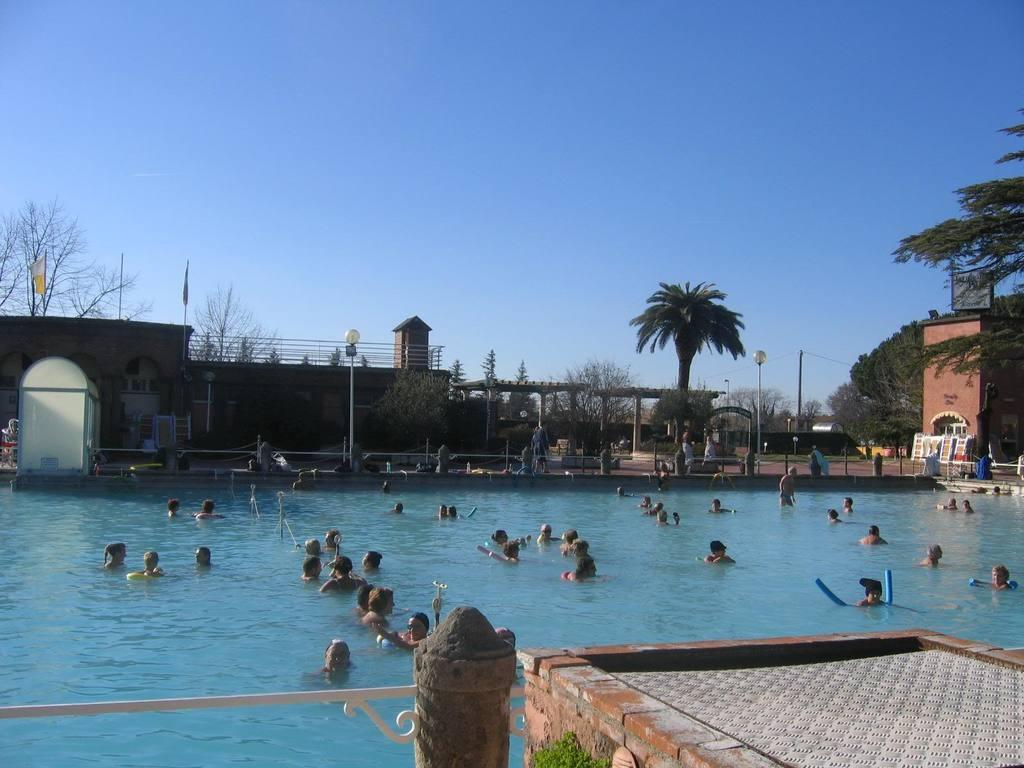What are the people in the image doing? The people in the image are in the water. What can be seen in the background near the water? There are trees, buildings, and poles beside the water. Are there any objects for sitting near the water? Yes, there are chairs beside the water. What degree of difficulty is the person in the water attempting to achieve? There is no indication of any difficulty level or achievement in the image; the people are simply in the water. 